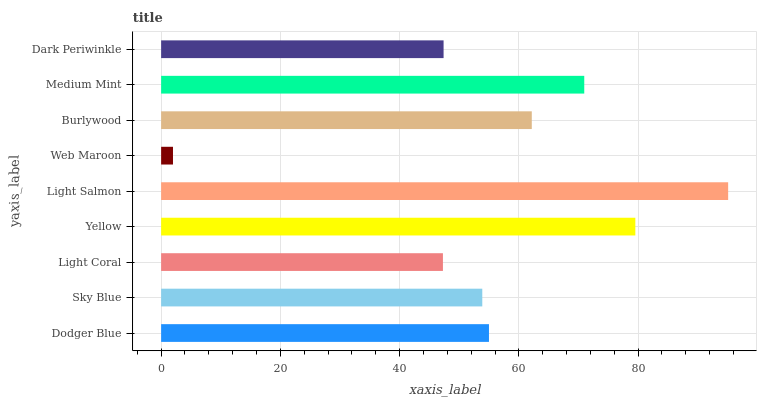Is Web Maroon the minimum?
Answer yes or no. Yes. Is Light Salmon the maximum?
Answer yes or no. Yes. Is Sky Blue the minimum?
Answer yes or no. No. Is Sky Blue the maximum?
Answer yes or no. No. Is Dodger Blue greater than Sky Blue?
Answer yes or no. Yes. Is Sky Blue less than Dodger Blue?
Answer yes or no. Yes. Is Sky Blue greater than Dodger Blue?
Answer yes or no. No. Is Dodger Blue less than Sky Blue?
Answer yes or no. No. Is Dodger Blue the high median?
Answer yes or no. Yes. Is Dodger Blue the low median?
Answer yes or no. Yes. Is Yellow the high median?
Answer yes or no. No. Is Medium Mint the low median?
Answer yes or no. No. 